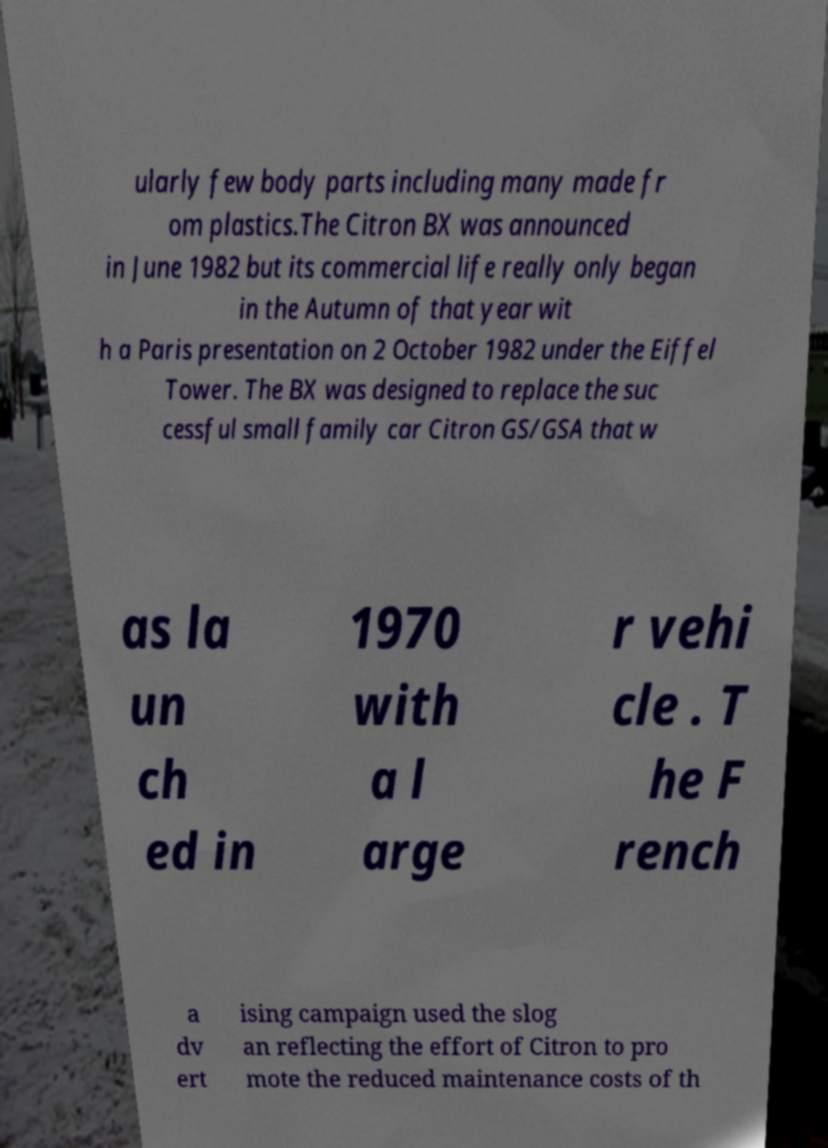Please identify and transcribe the text found in this image. ularly few body parts including many made fr om plastics.The Citron BX was announced in June 1982 but its commercial life really only began in the Autumn of that year wit h a Paris presentation on 2 October 1982 under the Eiffel Tower. The BX was designed to replace the suc cessful small family car Citron GS/GSA that w as la un ch ed in 1970 with a l arge r vehi cle . T he F rench a dv ert ising campaign used the slog an reflecting the effort of Citron to pro mote the reduced maintenance costs of th 